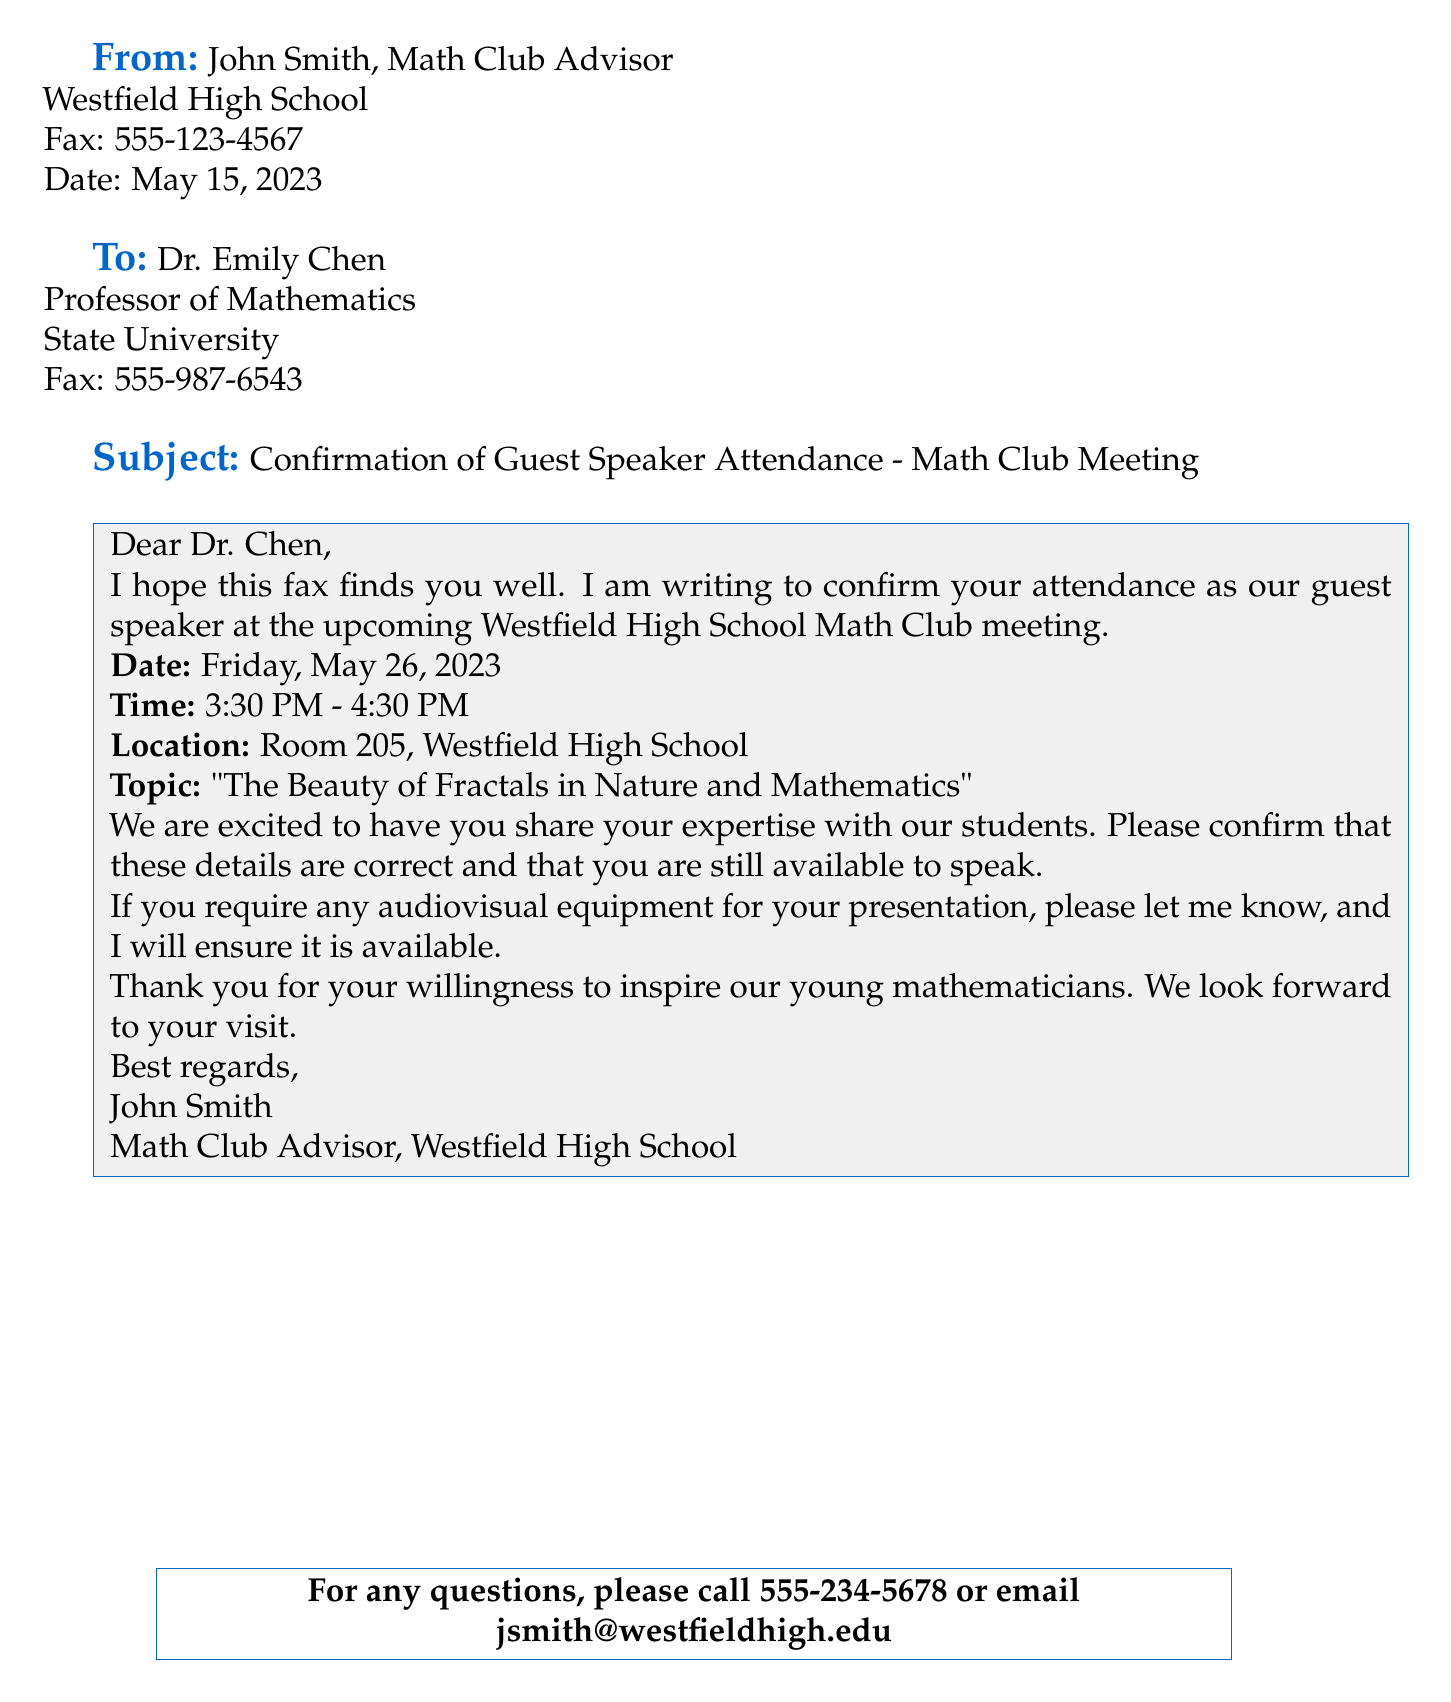What is the name of the guest speaker? The guest speaker is Dr. Emily Chen, as mentioned in the "To" section of the fax.
Answer: Dr. Emily Chen What is the topic of the upcoming presentation? The topic of the presentation is detailed in the body of the fax under "Topic".
Answer: The Beauty of Fractals in Nature and Mathematics What is the date of the Math Club meeting? The date is explicitly stated in the fax body under "Date".
Answer: Friday, May 26, 2023 What time does the event start? The starting time is provided in the fax body under "Time".
Answer: 3:30 PM What is the fax number of the Math Club advisor? The fax number is located at the top of the fax under "From".
Answer: 555-123-4567 How long is the Math Club meeting scheduled to last? The duration can be calculated from the times given in the "Time" section.
Answer: 1 hour What should Dr. Chen do if she needs audiovisual equipment? The fax states that Dr. Chen should inform John Smith if she has such a requirement.
Answer: Let me know What is the location of the Math Club meeting? The meeting location is specified in the body of the fax under "Location".
Answer: Room 205, Westfield High School What is the contact information for questions? The contact information is provided in the last part of the fax.
Answer: 555-234-5678 or email jsmith@westfieldhigh.edu 